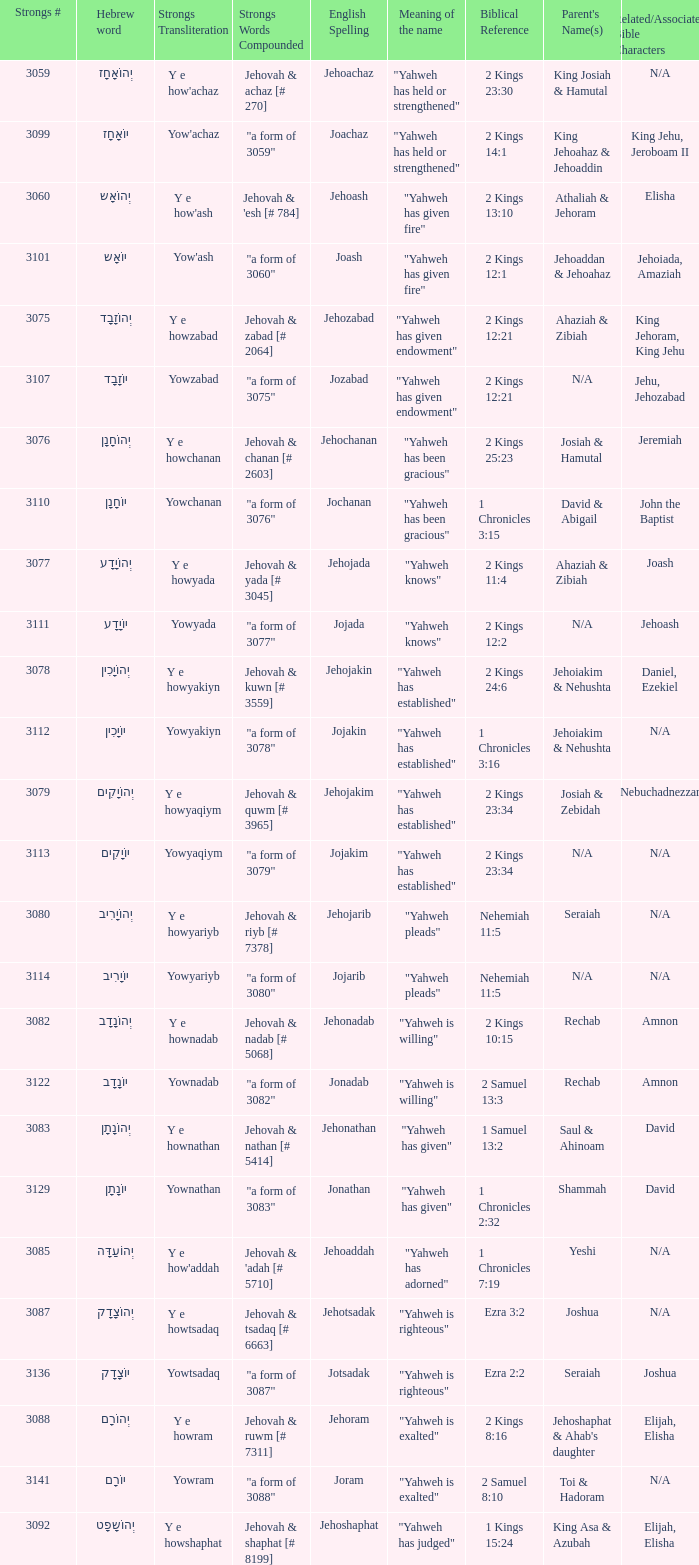How many strongs transliteration of the english spelling of the work jehojakin? 1.0. 